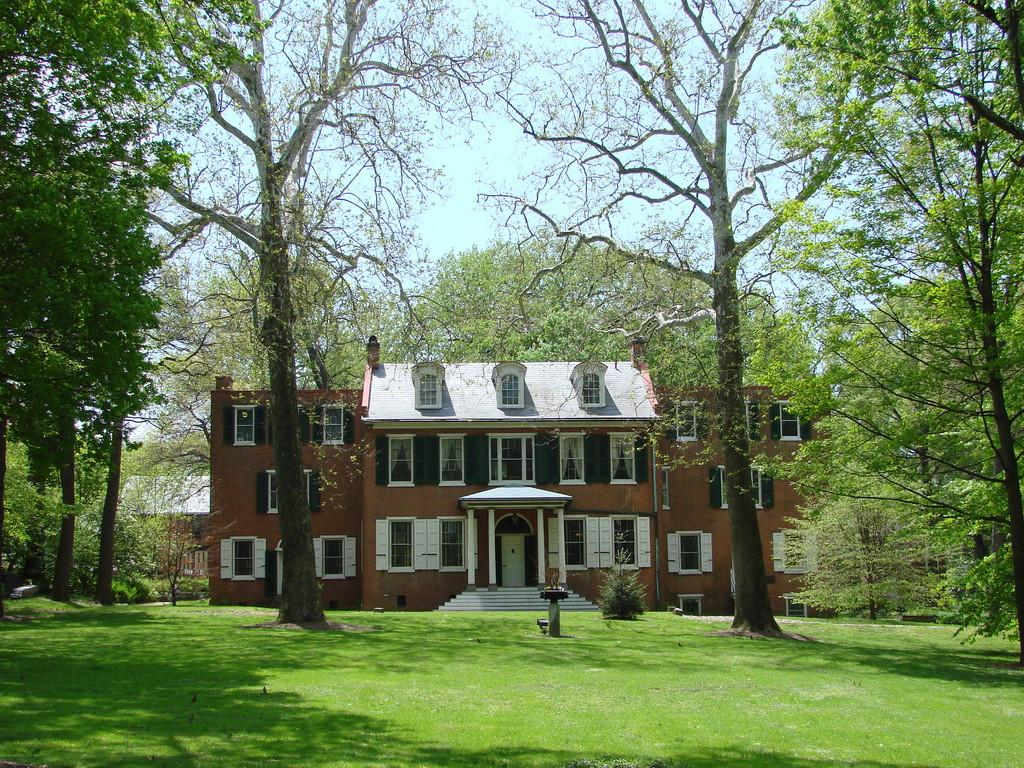What is the color of the building in the image? The building in the image is brown. What type of surface is on the ground in the image? There is grass on the ground in the image. What can be seen in the background of the image? There are trees and the sky visible in the background of the image. What type of silk is draped over the trees in the image? There is no silk present in the image; it features a brown building, grass, trees, and the sky. 